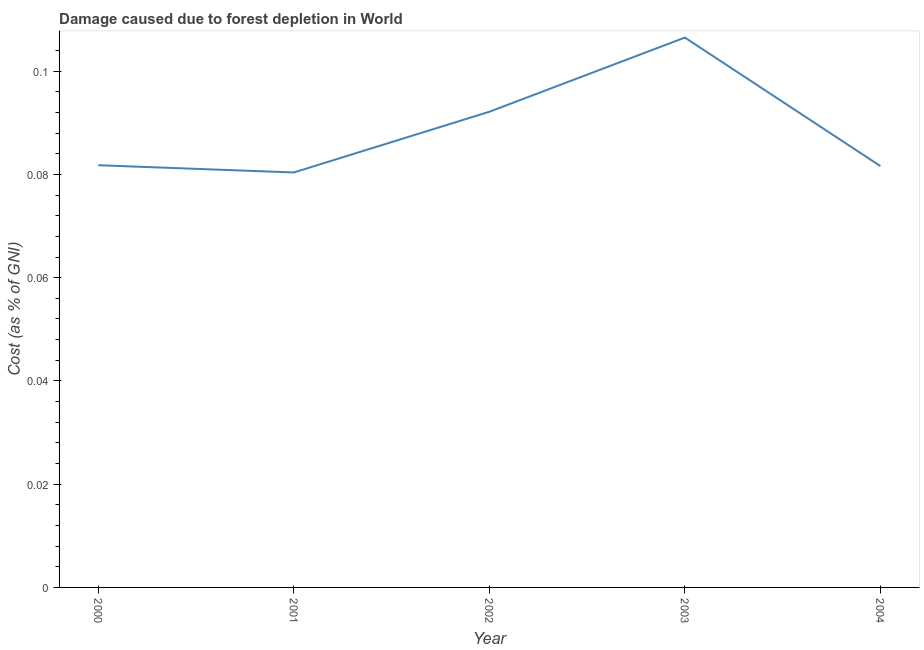What is the damage caused due to forest depletion in 2001?
Your response must be concise. 0.08. Across all years, what is the maximum damage caused due to forest depletion?
Provide a succinct answer. 0.11. Across all years, what is the minimum damage caused due to forest depletion?
Make the answer very short. 0.08. What is the sum of the damage caused due to forest depletion?
Ensure brevity in your answer.  0.44. What is the difference between the damage caused due to forest depletion in 2001 and 2004?
Your response must be concise. -0. What is the average damage caused due to forest depletion per year?
Your answer should be very brief. 0.09. What is the median damage caused due to forest depletion?
Keep it short and to the point. 0.08. What is the ratio of the damage caused due to forest depletion in 2000 to that in 2004?
Make the answer very short. 1. What is the difference between the highest and the second highest damage caused due to forest depletion?
Keep it short and to the point. 0.01. What is the difference between the highest and the lowest damage caused due to forest depletion?
Offer a terse response. 0.03. How many lines are there?
Provide a short and direct response. 1. How many years are there in the graph?
Make the answer very short. 5. What is the difference between two consecutive major ticks on the Y-axis?
Keep it short and to the point. 0.02. Are the values on the major ticks of Y-axis written in scientific E-notation?
Make the answer very short. No. Does the graph contain any zero values?
Provide a short and direct response. No. What is the title of the graph?
Give a very brief answer. Damage caused due to forest depletion in World. What is the label or title of the X-axis?
Keep it short and to the point. Year. What is the label or title of the Y-axis?
Your answer should be compact. Cost (as % of GNI). What is the Cost (as % of GNI) in 2000?
Your answer should be very brief. 0.08. What is the Cost (as % of GNI) of 2001?
Ensure brevity in your answer.  0.08. What is the Cost (as % of GNI) of 2002?
Offer a terse response. 0.09. What is the Cost (as % of GNI) in 2003?
Your answer should be compact. 0.11. What is the Cost (as % of GNI) in 2004?
Your response must be concise. 0.08. What is the difference between the Cost (as % of GNI) in 2000 and 2001?
Give a very brief answer. 0. What is the difference between the Cost (as % of GNI) in 2000 and 2002?
Your answer should be very brief. -0.01. What is the difference between the Cost (as % of GNI) in 2000 and 2003?
Keep it short and to the point. -0.02. What is the difference between the Cost (as % of GNI) in 2000 and 2004?
Offer a terse response. 0. What is the difference between the Cost (as % of GNI) in 2001 and 2002?
Your response must be concise. -0.01. What is the difference between the Cost (as % of GNI) in 2001 and 2003?
Give a very brief answer. -0.03. What is the difference between the Cost (as % of GNI) in 2001 and 2004?
Your response must be concise. -0. What is the difference between the Cost (as % of GNI) in 2002 and 2003?
Give a very brief answer. -0.01. What is the difference between the Cost (as % of GNI) in 2002 and 2004?
Give a very brief answer. 0.01. What is the difference between the Cost (as % of GNI) in 2003 and 2004?
Make the answer very short. 0.02. What is the ratio of the Cost (as % of GNI) in 2000 to that in 2002?
Ensure brevity in your answer.  0.89. What is the ratio of the Cost (as % of GNI) in 2000 to that in 2003?
Offer a very short reply. 0.77. What is the ratio of the Cost (as % of GNI) in 2000 to that in 2004?
Provide a succinct answer. 1. What is the ratio of the Cost (as % of GNI) in 2001 to that in 2002?
Offer a terse response. 0.87. What is the ratio of the Cost (as % of GNI) in 2001 to that in 2003?
Provide a succinct answer. 0.76. What is the ratio of the Cost (as % of GNI) in 2002 to that in 2003?
Offer a terse response. 0.86. What is the ratio of the Cost (as % of GNI) in 2002 to that in 2004?
Make the answer very short. 1.13. What is the ratio of the Cost (as % of GNI) in 2003 to that in 2004?
Keep it short and to the point. 1.3. 